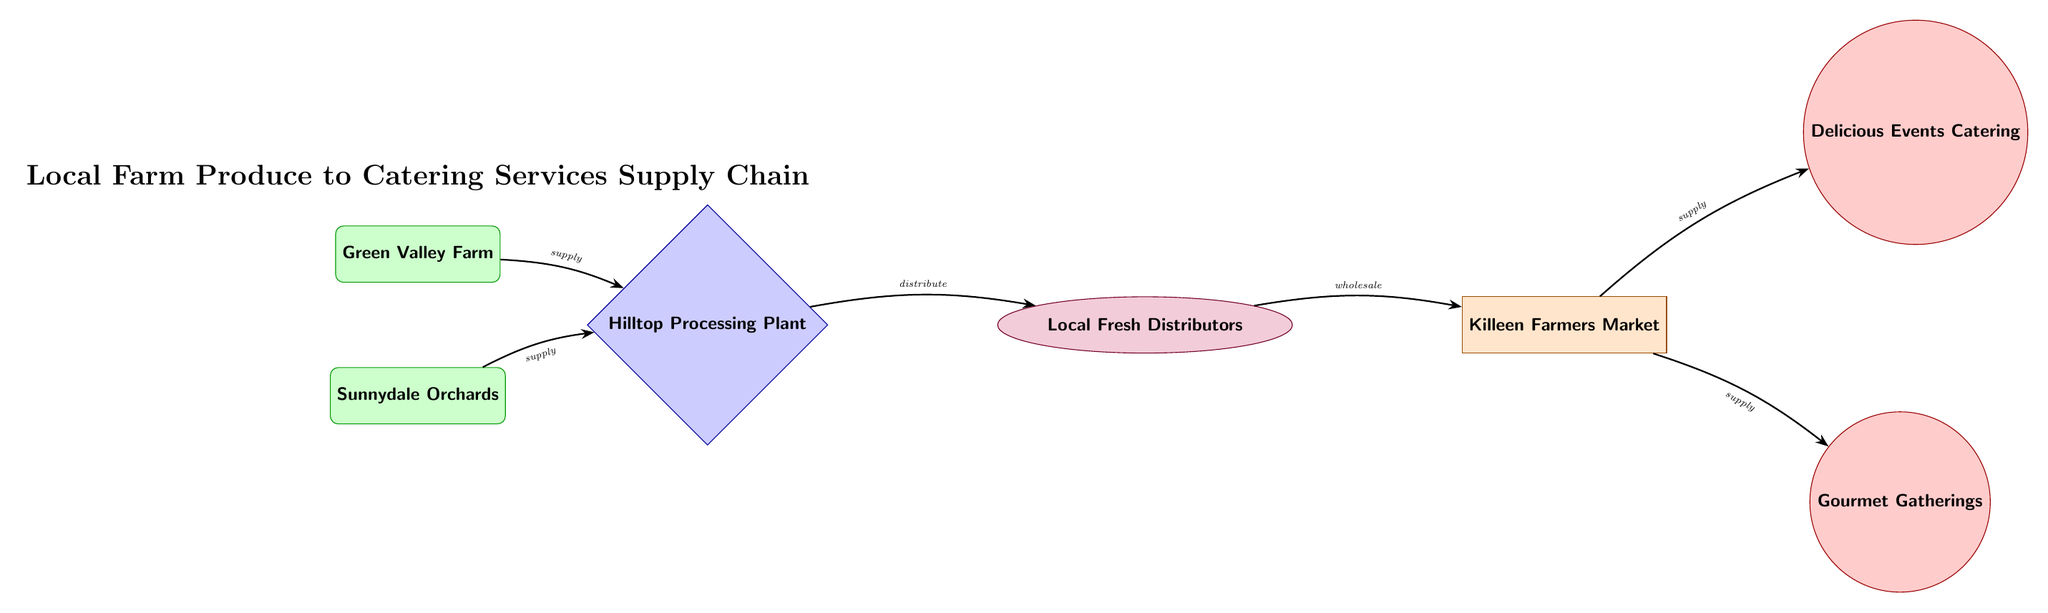What are the two farms in this supply chain? The diagram lists two producers, Green Valley Farm and Sunnydale Orchards, as the initial sources of local farm produce.
Answer: Green Valley Farm, Sunnydale Orchards How many caterers are represented in this supply chain? By counting the nodes designated as caterers, there are two caterers shown: Delicious Events Catering and Gourmet Gatherings.
Answer: 2 What type of entity is the Hilltop Processing Plant? The Hilltop Processing Plant is categorized in the diagram as a processor, as indicated by its diamond shape and label.
Answer: Processor Which entity supplies both caterers? The wholesaler, specifically the Killeen Farmers Market, supplies both caterers (Delicious Events Catering and Gourmet Gatherings) according to the arrows indicating supply direction from the wholesaler.
Answer: Killeen Farmers Market What is the flow of produce from the farms to the caterers? The flow starts at the farms (Green Valley Farm and Sunnydale Orchards), moves to the processor (Hilltop Processing Plant), then to the distributor (Local Fresh Distributors), next to the wholesaler (Killeen Farmers Market), and finally splits to supply both caterers.
Answer: Farms → Processor → Distributor → Wholesaler → Caterers Which node follows the processor in the supply chain? The Local Fresh Distributors node comes immediately after the processor (Hilltop Processing Plant) in the sequence of the food chain as shown by the connecting arrow.
Answer: Local Fresh Distributors What is the purpose of the edges in this diagram? The edges serve to illustrate the relationships and flow of products (like supply and distribution) between the different entities in the supply chain, as indicated by the labels on the arrows.
Answer: Relationships and flow How many total nodes (entities) are present in this supply chain diagram? Counting all the unique entities (farms, processor, distributor, wholesaler, and caterers), we find there are 6 nodes in total within the supply chain diagram.
Answer: 6 